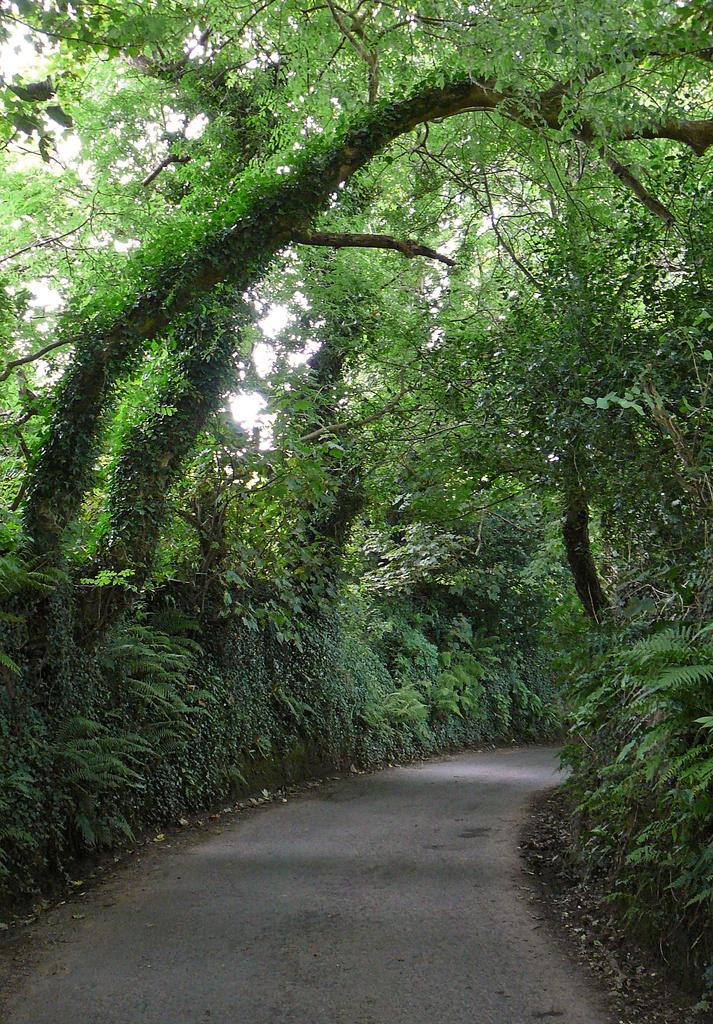What is the main feature in the center of the image? There is a road in the center of the image. What can be seen in the distance behind the road? There are trees visible in the background of the image. What type of substance is being used to create the road in the image? There is no information provided about the substance used to create the road in the image. --- Facts: 1. There is a person sitting on a bench in the image. 2. The person is reading a book. 3. There is a tree behind the bench. 4. The sky is visible in the image. Absurd Topics: parrot, dance, ocean Conversation: What is the person in the image doing? The person is sitting on a bench in the image. What activity is the person engaged in while sitting on the bench? The person is reading a book. What can be seen behind the bench in the image? There is a tree behind the bench. What is visible above the tree in the image? The sky is visible in the image. Reasoning: Let's think step by step in order to produce the conversation. We start by identifying the main subject in the image, which is the person sitting on the bench. Then, we expand the conversation to include the person's activity, which is reading a book. We also mention the tree and sky visible in the image. Each question is designed to elicit a specific detail about the image that is known from the provided facts. Absurd Question/Answer: Can you see a parrot dancing near the ocean in the image? There is no parrot or ocean present in the image. 